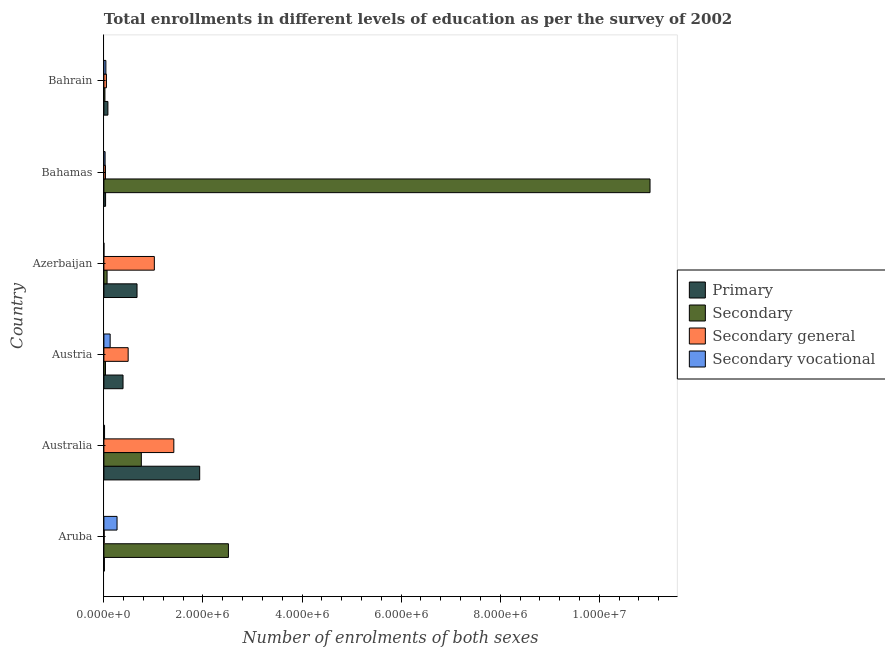How many groups of bars are there?
Offer a terse response. 6. Are the number of bars per tick equal to the number of legend labels?
Provide a short and direct response. Yes. Are the number of bars on each tick of the Y-axis equal?
Offer a terse response. Yes. How many bars are there on the 3rd tick from the top?
Provide a succinct answer. 4. How many bars are there on the 2nd tick from the bottom?
Your response must be concise. 4. What is the label of the 6th group of bars from the top?
Your answer should be very brief. Aruba. What is the number of enrolments in secondary general education in Bahamas?
Your answer should be very brief. 3.17e+04. Across all countries, what is the maximum number of enrolments in secondary education?
Your response must be concise. 1.10e+07. Across all countries, what is the minimum number of enrolments in primary education?
Keep it short and to the point. 9840. In which country was the number of enrolments in secondary general education maximum?
Provide a succinct answer. Australia. In which country was the number of enrolments in primary education minimum?
Offer a terse response. Aruba. What is the total number of enrolments in primary education in the graph?
Ensure brevity in your answer.  3.11e+06. What is the difference between the number of enrolments in primary education in Austria and that in Azerbaijan?
Provide a short and direct response. -2.82e+05. What is the difference between the number of enrolments in secondary vocational education in Azerbaijan and the number of enrolments in secondary general education in Aruba?
Provide a succinct answer. -5449. What is the average number of enrolments in primary education per country?
Keep it short and to the point. 5.19e+05. What is the difference between the number of enrolments in primary education and number of enrolments in secondary education in Bahrain?
Your answer should be very brief. 6.02e+04. What is the ratio of the number of enrolments in secondary general education in Azerbaijan to that in Bahamas?
Offer a very short reply. 32.12. What is the difference between the highest and the second highest number of enrolments in secondary vocational education?
Offer a terse response. 1.39e+05. What is the difference between the highest and the lowest number of enrolments in secondary vocational education?
Offer a terse response. 2.66e+05. In how many countries, is the number of enrolments in secondary vocational education greater than the average number of enrolments in secondary vocational education taken over all countries?
Your answer should be compact. 2. What does the 2nd bar from the top in Australia represents?
Offer a terse response. Secondary general. What does the 3rd bar from the bottom in Azerbaijan represents?
Provide a succinct answer. Secondary general. How many bars are there?
Offer a terse response. 24. How many countries are there in the graph?
Your answer should be very brief. 6. Are the values on the major ticks of X-axis written in scientific E-notation?
Offer a very short reply. Yes. Does the graph contain grids?
Your answer should be compact. No. Where does the legend appear in the graph?
Provide a succinct answer. Center right. How are the legend labels stacked?
Offer a very short reply. Vertical. What is the title of the graph?
Give a very brief answer. Total enrollments in different levels of education as per the survey of 2002. What is the label or title of the X-axis?
Ensure brevity in your answer.  Number of enrolments of both sexes. What is the label or title of the Y-axis?
Keep it short and to the point. Country. What is the Number of enrolments of both sexes in Primary in Aruba?
Your answer should be very brief. 9840. What is the Number of enrolments of both sexes of Secondary in Aruba?
Offer a terse response. 2.51e+06. What is the Number of enrolments of both sexes in Secondary general in Aruba?
Your response must be concise. 5559. What is the Number of enrolments of both sexes in Secondary vocational in Aruba?
Provide a short and direct response. 2.66e+05. What is the Number of enrolments of both sexes of Primary in Australia?
Your answer should be very brief. 1.93e+06. What is the Number of enrolments of both sexes of Secondary in Australia?
Ensure brevity in your answer.  7.56e+05. What is the Number of enrolments of both sexes of Secondary general in Australia?
Offer a very short reply. 1.41e+06. What is the Number of enrolments of both sexes in Secondary vocational in Australia?
Keep it short and to the point. 1.31e+04. What is the Number of enrolments of both sexes of Primary in Austria?
Make the answer very short. 3.86e+05. What is the Number of enrolments of both sexes in Secondary in Austria?
Ensure brevity in your answer.  3.17e+04. What is the Number of enrolments of both sexes in Secondary general in Austria?
Your answer should be very brief. 4.90e+05. What is the Number of enrolments of both sexes of Secondary vocational in Austria?
Give a very brief answer. 1.26e+05. What is the Number of enrolments of both sexes of Primary in Azerbaijan?
Provide a succinct answer. 6.69e+05. What is the Number of enrolments of both sexes in Secondary in Azerbaijan?
Your response must be concise. 6.44e+04. What is the Number of enrolments of both sexes in Secondary general in Azerbaijan?
Offer a very short reply. 1.02e+06. What is the Number of enrolments of both sexes in Secondary vocational in Azerbaijan?
Provide a succinct answer. 110. What is the Number of enrolments of both sexes of Primary in Bahamas?
Offer a terse response. 3.42e+04. What is the Number of enrolments of both sexes in Secondary in Bahamas?
Provide a short and direct response. 1.10e+07. What is the Number of enrolments of both sexes in Secondary general in Bahamas?
Your answer should be very brief. 3.17e+04. What is the Number of enrolments of both sexes of Secondary vocational in Bahamas?
Your answer should be very brief. 2.43e+04. What is the Number of enrolments of both sexes in Primary in Bahrain?
Provide a succinct answer. 8.11e+04. What is the Number of enrolments of both sexes of Secondary in Bahrain?
Keep it short and to the point. 2.09e+04. What is the Number of enrolments of both sexes in Secondary general in Bahrain?
Your answer should be compact. 5.13e+04. What is the Number of enrolments of both sexes in Secondary vocational in Bahrain?
Your response must be concise. 4.00e+04. Across all countries, what is the maximum Number of enrolments of both sexes in Primary?
Offer a terse response. 1.93e+06. Across all countries, what is the maximum Number of enrolments of both sexes in Secondary?
Provide a succinct answer. 1.10e+07. Across all countries, what is the maximum Number of enrolments of both sexes of Secondary general?
Provide a succinct answer. 1.41e+06. Across all countries, what is the maximum Number of enrolments of both sexes in Secondary vocational?
Ensure brevity in your answer.  2.66e+05. Across all countries, what is the minimum Number of enrolments of both sexes of Primary?
Offer a very short reply. 9840. Across all countries, what is the minimum Number of enrolments of both sexes in Secondary?
Your answer should be very brief. 2.09e+04. Across all countries, what is the minimum Number of enrolments of both sexes of Secondary general?
Provide a succinct answer. 5559. Across all countries, what is the minimum Number of enrolments of both sexes in Secondary vocational?
Make the answer very short. 110. What is the total Number of enrolments of both sexes of Primary in the graph?
Your answer should be very brief. 3.11e+06. What is the total Number of enrolments of both sexes of Secondary in the graph?
Give a very brief answer. 1.44e+07. What is the total Number of enrolments of both sexes in Secondary general in the graph?
Offer a terse response. 3.01e+06. What is the total Number of enrolments of both sexes of Secondary vocational in the graph?
Offer a very short reply. 4.70e+05. What is the difference between the Number of enrolments of both sexes of Primary in Aruba and that in Australia?
Your response must be concise. -1.92e+06. What is the difference between the Number of enrolments of both sexes in Secondary in Aruba and that in Australia?
Offer a terse response. 1.76e+06. What is the difference between the Number of enrolments of both sexes of Secondary general in Aruba and that in Australia?
Your answer should be compact. -1.41e+06. What is the difference between the Number of enrolments of both sexes of Secondary vocational in Aruba and that in Australia?
Provide a short and direct response. 2.53e+05. What is the difference between the Number of enrolments of both sexes of Primary in Aruba and that in Austria?
Offer a terse response. -3.77e+05. What is the difference between the Number of enrolments of both sexes of Secondary in Aruba and that in Austria?
Provide a short and direct response. 2.48e+06. What is the difference between the Number of enrolments of both sexes in Secondary general in Aruba and that in Austria?
Your answer should be very brief. -4.84e+05. What is the difference between the Number of enrolments of both sexes in Secondary vocational in Aruba and that in Austria?
Give a very brief answer. 1.39e+05. What is the difference between the Number of enrolments of both sexes of Primary in Aruba and that in Azerbaijan?
Provide a short and direct response. -6.59e+05. What is the difference between the Number of enrolments of both sexes of Secondary in Aruba and that in Azerbaijan?
Provide a short and direct response. 2.45e+06. What is the difference between the Number of enrolments of both sexes of Secondary general in Aruba and that in Azerbaijan?
Your response must be concise. -1.01e+06. What is the difference between the Number of enrolments of both sexes in Secondary vocational in Aruba and that in Azerbaijan?
Keep it short and to the point. 2.66e+05. What is the difference between the Number of enrolments of both sexes in Primary in Aruba and that in Bahamas?
Give a very brief answer. -2.43e+04. What is the difference between the Number of enrolments of both sexes in Secondary in Aruba and that in Bahamas?
Provide a short and direct response. -8.51e+06. What is the difference between the Number of enrolments of both sexes of Secondary general in Aruba and that in Bahamas?
Provide a short and direct response. -2.62e+04. What is the difference between the Number of enrolments of both sexes in Secondary vocational in Aruba and that in Bahamas?
Your response must be concise. 2.41e+05. What is the difference between the Number of enrolments of both sexes in Primary in Aruba and that in Bahrain?
Your answer should be very brief. -7.12e+04. What is the difference between the Number of enrolments of both sexes in Secondary in Aruba and that in Bahrain?
Your answer should be compact. 2.49e+06. What is the difference between the Number of enrolments of both sexes in Secondary general in Aruba and that in Bahrain?
Your answer should be very brief. -4.58e+04. What is the difference between the Number of enrolments of both sexes of Secondary vocational in Aruba and that in Bahrain?
Your answer should be very brief. 2.26e+05. What is the difference between the Number of enrolments of both sexes of Primary in Australia and that in Austria?
Your answer should be compact. 1.55e+06. What is the difference between the Number of enrolments of both sexes in Secondary in Australia and that in Austria?
Provide a short and direct response. 7.24e+05. What is the difference between the Number of enrolments of both sexes of Secondary general in Australia and that in Austria?
Offer a terse response. 9.22e+05. What is the difference between the Number of enrolments of both sexes of Secondary vocational in Australia and that in Austria?
Make the answer very short. -1.13e+05. What is the difference between the Number of enrolments of both sexes in Primary in Australia and that in Azerbaijan?
Provide a short and direct response. 1.26e+06. What is the difference between the Number of enrolments of both sexes of Secondary in Australia and that in Azerbaijan?
Make the answer very short. 6.91e+05. What is the difference between the Number of enrolments of both sexes in Secondary general in Australia and that in Azerbaijan?
Provide a short and direct response. 3.93e+05. What is the difference between the Number of enrolments of both sexes in Secondary vocational in Australia and that in Azerbaijan?
Give a very brief answer. 1.30e+04. What is the difference between the Number of enrolments of both sexes in Primary in Australia and that in Bahamas?
Your answer should be very brief. 1.90e+06. What is the difference between the Number of enrolments of both sexes in Secondary in Australia and that in Bahamas?
Give a very brief answer. -1.03e+07. What is the difference between the Number of enrolments of both sexes in Secondary general in Australia and that in Bahamas?
Offer a very short reply. 1.38e+06. What is the difference between the Number of enrolments of both sexes of Secondary vocational in Australia and that in Bahamas?
Ensure brevity in your answer.  -1.12e+04. What is the difference between the Number of enrolments of both sexes in Primary in Australia and that in Bahrain?
Provide a short and direct response. 1.85e+06. What is the difference between the Number of enrolments of both sexes in Secondary in Australia and that in Bahrain?
Your answer should be compact. 7.35e+05. What is the difference between the Number of enrolments of both sexes of Secondary general in Australia and that in Bahrain?
Your answer should be compact. 1.36e+06. What is the difference between the Number of enrolments of both sexes of Secondary vocational in Australia and that in Bahrain?
Give a very brief answer. -2.69e+04. What is the difference between the Number of enrolments of both sexes of Primary in Austria and that in Azerbaijan?
Offer a very short reply. -2.82e+05. What is the difference between the Number of enrolments of both sexes of Secondary in Austria and that in Azerbaijan?
Ensure brevity in your answer.  -3.27e+04. What is the difference between the Number of enrolments of both sexes in Secondary general in Austria and that in Azerbaijan?
Offer a very short reply. -5.29e+05. What is the difference between the Number of enrolments of both sexes in Secondary vocational in Austria and that in Azerbaijan?
Provide a short and direct response. 1.26e+05. What is the difference between the Number of enrolments of both sexes in Primary in Austria and that in Bahamas?
Your response must be concise. 3.52e+05. What is the difference between the Number of enrolments of both sexes of Secondary in Austria and that in Bahamas?
Make the answer very short. -1.10e+07. What is the difference between the Number of enrolments of both sexes of Secondary general in Austria and that in Bahamas?
Give a very brief answer. 4.58e+05. What is the difference between the Number of enrolments of both sexes of Secondary vocational in Austria and that in Bahamas?
Offer a terse response. 1.02e+05. What is the difference between the Number of enrolments of both sexes of Primary in Austria and that in Bahrain?
Ensure brevity in your answer.  3.05e+05. What is the difference between the Number of enrolments of both sexes in Secondary in Austria and that in Bahrain?
Keep it short and to the point. 1.08e+04. What is the difference between the Number of enrolments of both sexes in Secondary general in Austria and that in Bahrain?
Keep it short and to the point. 4.39e+05. What is the difference between the Number of enrolments of both sexes in Secondary vocational in Austria and that in Bahrain?
Make the answer very short. 8.63e+04. What is the difference between the Number of enrolments of both sexes in Primary in Azerbaijan and that in Bahamas?
Your answer should be compact. 6.35e+05. What is the difference between the Number of enrolments of both sexes in Secondary in Azerbaijan and that in Bahamas?
Your response must be concise. -1.10e+07. What is the difference between the Number of enrolments of both sexes in Secondary general in Azerbaijan and that in Bahamas?
Give a very brief answer. 9.87e+05. What is the difference between the Number of enrolments of both sexes of Secondary vocational in Azerbaijan and that in Bahamas?
Offer a terse response. -2.42e+04. What is the difference between the Number of enrolments of both sexes of Primary in Azerbaijan and that in Bahrain?
Your answer should be very brief. 5.88e+05. What is the difference between the Number of enrolments of both sexes in Secondary in Azerbaijan and that in Bahrain?
Provide a succinct answer. 4.36e+04. What is the difference between the Number of enrolments of both sexes of Secondary general in Azerbaijan and that in Bahrain?
Provide a short and direct response. 9.67e+05. What is the difference between the Number of enrolments of both sexes in Secondary vocational in Azerbaijan and that in Bahrain?
Provide a short and direct response. -3.99e+04. What is the difference between the Number of enrolments of both sexes of Primary in Bahamas and that in Bahrain?
Provide a short and direct response. -4.69e+04. What is the difference between the Number of enrolments of both sexes in Secondary in Bahamas and that in Bahrain?
Ensure brevity in your answer.  1.10e+07. What is the difference between the Number of enrolments of both sexes in Secondary general in Bahamas and that in Bahrain?
Your response must be concise. -1.96e+04. What is the difference between the Number of enrolments of both sexes in Secondary vocational in Bahamas and that in Bahrain?
Provide a succinct answer. -1.57e+04. What is the difference between the Number of enrolments of both sexes of Primary in Aruba and the Number of enrolments of both sexes of Secondary in Australia?
Your response must be concise. -7.46e+05. What is the difference between the Number of enrolments of both sexes in Primary in Aruba and the Number of enrolments of both sexes in Secondary general in Australia?
Provide a short and direct response. -1.40e+06. What is the difference between the Number of enrolments of both sexes of Primary in Aruba and the Number of enrolments of both sexes of Secondary vocational in Australia?
Keep it short and to the point. -3275. What is the difference between the Number of enrolments of both sexes in Secondary in Aruba and the Number of enrolments of both sexes in Secondary general in Australia?
Your answer should be compact. 1.10e+06. What is the difference between the Number of enrolments of both sexes of Secondary in Aruba and the Number of enrolments of both sexes of Secondary vocational in Australia?
Your answer should be very brief. 2.50e+06. What is the difference between the Number of enrolments of both sexes of Secondary general in Aruba and the Number of enrolments of both sexes of Secondary vocational in Australia?
Your response must be concise. -7556. What is the difference between the Number of enrolments of both sexes in Primary in Aruba and the Number of enrolments of both sexes in Secondary in Austria?
Give a very brief answer. -2.19e+04. What is the difference between the Number of enrolments of both sexes in Primary in Aruba and the Number of enrolments of both sexes in Secondary general in Austria?
Offer a terse response. -4.80e+05. What is the difference between the Number of enrolments of both sexes in Primary in Aruba and the Number of enrolments of both sexes in Secondary vocational in Austria?
Your answer should be very brief. -1.17e+05. What is the difference between the Number of enrolments of both sexes of Secondary in Aruba and the Number of enrolments of both sexes of Secondary general in Austria?
Offer a terse response. 2.02e+06. What is the difference between the Number of enrolments of both sexes in Secondary in Aruba and the Number of enrolments of both sexes in Secondary vocational in Austria?
Your answer should be very brief. 2.39e+06. What is the difference between the Number of enrolments of both sexes in Secondary general in Aruba and the Number of enrolments of both sexes in Secondary vocational in Austria?
Offer a terse response. -1.21e+05. What is the difference between the Number of enrolments of both sexes of Primary in Aruba and the Number of enrolments of both sexes of Secondary in Azerbaijan?
Make the answer very short. -5.46e+04. What is the difference between the Number of enrolments of both sexes in Primary in Aruba and the Number of enrolments of both sexes in Secondary general in Azerbaijan?
Offer a terse response. -1.01e+06. What is the difference between the Number of enrolments of both sexes of Primary in Aruba and the Number of enrolments of both sexes of Secondary vocational in Azerbaijan?
Your answer should be very brief. 9730. What is the difference between the Number of enrolments of both sexes in Secondary in Aruba and the Number of enrolments of both sexes in Secondary general in Azerbaijan?
Provide a succinct answer. 1.50e+06. What is the difference between the Number of enrolments of both sexes of Secondary in Aruba and the Number of enrolments of both sexes of Secondary vocational in Azerbaijan?
Your response must be concise. 2.51e+06. What is the difference between the Number of enrolments of both sexes of Secondary general in Aruba and the Number of enrolments of both sexes of Secondary vocational in Azerbaijan?
Ensure brevity in your answer.  5449. What is the difference between the Number of enrolments of both sexes of Primary in Aruba and the Number of enrolments of both sexes of Secondary in Bahamas?
Your answer should be very brief. -1.10e+07. What is the difference between the Number of enrolments of both sexes in Primary in Aruba and the Number of enrolments of both sexes in Secondary general in Bahamas?
Ensure brevity in your answer.  -2.19e+04. What is the difference between the Number of enrolments of both sexes of Primary in Aruba and the Number of enrolments of both sexes of Secondary vocational in Bahamas?
Your answer should be compact. -1.45e+04. What is the difference between the Number of enrolments of both sexes in Secondary in Aruba and the Number of enrolments of both sexes in Secondary general in Bahamas?
Offer a very short reply. 2.48e+06. What is the difference between the Number of enrolments of both sexes in Secondary in Aruba and the Number of enrolments of both sexes in Secondary vocational in Bahamas?
Make the answer very short. 2.49e+06. What is the difference between the Number of enrolments of both sexes in Secondary general in Aruba and the Number of enrolments of both sexes in Secondary vocational in Bahamas?
Provide a succinct answer. -1.88e+04. What is the difference between the Number of enrolments of both sexes in Primary in Aruba and the Number of enrolments of both sexes in Secondary in Bahrain?
Keep it short and to the point. -1.10e+04. What is the difference between the Number of enrolments of both sexes in Primary in Aruba and the Number of enrolments of both sexes in Secondary general in Bahrain?
Make the answer very short. -4.15e+04. What is the difference between the Number of enrolments of both sexes in Primary in Aruba and the Number of enrolments of both sexes in Secondary vocational in Bahrain?
Offer a terse response. -3.02e+04. What is the difference between the Number of enrolments of both sexes of Secondary in Aruba and the Number of enrolments of both sexes of Secondary general in Bahrain?
Make the answer very short. 2.46e+06. What is the difference between the Number of enrolments of both sexes of Secondary in Aruba and the Number of enrolments of both sexes of Secondary vocational in Bahrain?
Keep it short and to the point. 2.47e+06. What is the difference between the Number of enrolments of both sexes in Secondary general in Aruba and the Number of enrolments of both sexes in Secondary vocational in Bahrain?
Offer a very short reply. -3.45e+04. What is the difference between the Number of enrolments of both sexes of Primary in Australia and the Number of enrolments of both sexes of Secondary in Austria?
Keep it short and to the point. 1.90e+06. What is the difference between the Number of enrolments of both sexes of Primary in Australia and the Number of enrolments of both sexes of Secondary general in Austria?
Your answer should be compact. 1.44e+06. What is the difference between the Number of enrolments of both sexes of Primary in Australia and the Number of enrolments of both sexes of Secondary vocational in Austria?
Offer a terse response. 1.81e+06. What is the difference between the Number of enrolments of both sexes of Secondary in Australia and the Number of enrolments of both sexes of Secondary general in Austria?
Offer a very short reply. 2.66e+05. What is the difference between the Number of enrolments of both sexes in Secondary in Australia and the Number of enrolments of both sexes in Secondary vocational in Austria?
Give a very brief answer. 6.29e+05. What is the difference between the Number of enrolments of both sexes in Secondary general in Australia and the Number of enrolments of both sexes in Secondary vocational in Austria?
Provide a short and direct response. 1.29e+06. What is the difference between the Number of enrolments of both sexes of Primary in Australia and the Number of enrolments of both sexes of Secondary in Azerbaijan?
Provide a short and direct response. 1.87e+06. What is the difference between the Number of enrolments of both sexes of Primary in Australia and the Number of enrolments of both sexes of Secondary general in Azerbaijan?
Offer a terse response. 9.15e+05. What is the difference between the Number of enrolments of both sexes of Primary in Australia and the Number of enrolments of both sexes of Secondary vocational in Azerbaijan?
Give a very brief answer. 1.93e+06. What is the difference between the Number of enrolments of both sexes in Secondary in Australia and the Number of enrolments of both sexes in Secondary general in Azerbaijan?
Your response must be concise. -2.63e+05. What is the difference between the Number of enrolments of both sexes in Secondary in Australia and the Number of enrolments of both sexes in Secondary vocational in Azerbaijan?
Keep it short and to the point. 7.55e+05. What is the difference between the Number of enrolments of both sexes of Secondary general in Australia and the Number of enrolments of both sexes of Secondary vocational in Azerbaijan?
Your response must be concise. 1.41e+06. What is the difference between the Number of enrolments of both sexes in Primary in Australia and the Number of enrolments of both sexes in Secondary in Bahamas?
Offer a very short reply. -9.09e+06. What is the difference between the Number of enrolments of both sexes of Primary in Australia and the Number of enrolments of both sexes of Secondary general in Bahamas?
Your answer should be compact. 1.90e+06. What is the difference between the Number of enrolments of both sexes in Primary in Australia and the Number of enrolments of both sexes in Secondary vocational in Bahamas?
Give a very brief answer. 1.91e+06. What is the difference between the Number of enrolments of both sexes of Secondary in Australia and the Number of enrolments of both sexes of Secondary general in Bahamas?
Ensure brevity in your answer.  7.24e+05. What is the difference between the Number of enrolments of both sexes in Secondary in Australia and the Number of enrolments of both sexes in Secondary vocational in Bahamas?
Provide a short and direct response. 7.31e+05. What is the difference between the Number of enrolments of both sexes in Secondary general in Australia and the Number of enrolments of both sexes in Secondary vocational in Bahamas?
Your answer should be very brief. 1.39e+06. What is the difference between the Number of enrolments of both sexes of Primary in Australia and the Number of enrolments of both sexes of Secondary in Bahrain?
Provide a succinct answer. 1.91e+06. What is the difference between the Number of enrolments of both sexes in Primary in Australia and the Number of enrolments of both sexes in Secondary general in Bahrain?
Your answer should be very brief. 1.88e+06. What is the difference between the Number of enrolments of both sexes of Primary in Australia and the Number of enrolments of both sexes of Secondary vocational in Bahrain?
Your answer should be compact. 1.89e+06. What is the difference between the Number of enrolments of both sexes of Secondary in Australia and the Number of enrolments of both sexes of Secondary general in Bahrain?
Your response must be concise. 7.04e+05. What is the difference between the Number of enrolments of both sexes in Secondary in Australia and the Number of enrolments of both sexes in Secondary vocational in Bahrain?
Give a very brief answer. 7.16e+05. What is the difference between the Number of enrolments of both sexes in Secondary general in Australia and the Number of enrolments of both sexes in Secondary vocational in Bahrain?
Your answer should be compact. 1.37e+06. What is the difference between the Number of enrolments of both sexes of Primary in Austria and the Number of enrolments of both sexes of Secondary in Azerbaijan?
Your answer should be compact. 3.22e+05. What is the difference between the Number of enrolments of both sexes in Primary in Austria and the Number of enrolments of both sexes in Secondary general in Azerbaijan?
Your answer should be compact. -6.32e+05. What is the difference between the Number of enrolments of both sexes of Primary in Austria and the Number of enrolments of both sexes of Secondary vocational in Azerbaijan?
Offer a very short reply. 3.86e+05. What is the difference between the Number of enrolments of both sexes of Secondary in Austria and the Number of enrolments of both sexes of Secondary general in Azerbaijan?
Keep it short and to the point. -9.87e+05. What is the difference between the Number of enrolments of both sexes of Secondary in Austria and the Number of enrolments of both sexes of Secondary vocational in Azerbaijan?
Provide a short and direct response. 3.16e+04. What is the difference between the Number of enrolments of both sexes of Secondary general in Austria and the Number of enrolments of both sexes of Secondary vocational in Azerbaijan?
Provide a succinct answer. 4.90e+05. What is the difference between the Number of enrolments of both sexes in Primary in Austria and the Number of enrolments of both sexes in Secondary in Bahamas?
Your answer should be compact. -1.06e+07. What is the difference between the Number of enrolments of both sexes in Primary in Austria and the Number of enrolments of both sexes in Secondary general in Bahamas?
Your answer should be very brief. 3.55e+05. What is the difference between the Number of enrolments of both sexes of Primary in Austria and the Number of enrolments of both sexes of Secondary vocational in Bahamas?
Keep it short and to the point. 3.62e+05. What is the difference between the Number of enrolments of both sexes in Secondary in Austria and the Number of enrolments of both sexes in Secondary general in Bahamas?
Make the answer very short. 0. What is the difference between the Number of enrolments of both sexes in Secondary in Austria and the Number of enrolments of both sexes in Secondary vocational in Bahamas?
Offer a terse response. 7371. What is the difference between the Number of enrolments of both sexes of Secondary general in Austria and the Number of enrolments of both sexes of Secondary vocational in Bahamas?
Offer a terse response. 4.66e+05. What is the difference between the Number of enrolments of both sexes in Primary in Austria and the Number of enrolments of both sexes in Secondary in Bahrain?
Offer a very short reply. 3.66e+05. What is the difference between the Number of enrolments of both sexes of Primary in Austria and the Number of enrolments of both sexes of Secondary general in Bahrain?
Your answer should be compact. 3.35e+05. What is the difference between the Number of enrolments of both sexes in Primary in Austria and the Number of enrolments of both sexes in Secondary vocational in Bahrain?
Ensure brevity in your answer.  3.46e+05. What is the difference between the Number of enrolments of both sexes of Secondary in Austria and the Number of enrolments of both sexes of Secondary general in Bahrain?
Provide a short and direct response. -1.96e+04. What is the difference between the Number of enrolments of both sexes in Secondary in Austria and the Number of enrolments of both sexes in Secondary vocational in Bahrain?
Provide a short and direct response. -8317. What is the difference between the Number of enrolments of both sexes in Secondary general in Austria and the Number of enrolments of both sexes in Secondary vocational in Bahrain?
Offer a terse response. 4.50e+05. What is the difference between the Number of enrolments of both sexes in Primary in Azerbaijan and the Number of enrolments of both sexes in Secondary in Bahamas?
Your answer should be compact. -1.04e+07. What is the difference between the Number of enrolments of both sexes of Primary in Azerbaijan and the Number of enrolments of both sexes of Secondary general in Bahamas?
Offer a very short reply. 6.37e+05. What is the difference between the Number of enrolments of both sexes of Primary in Azerbaijan and the Number of enrolments of both sexes of Secondary vocational in Bahamas?
Your answer should be compact. 6.45e+05. What is the difference between the Number of enrolments of both sexes in Secondary in Azerbaijan and the Number of enrolments of both sexes in Secondary general in Bahamas?
Keep it short and to the point. 3.27e+04. What is the difference between the Number of enrolments of both sexes in Secondary in Azerbaijan and the Number of enrolments of both sexes in Secondary vocational in Bahamas?
Offer a terse response. 4.01e+04. What is the difference between the Number of enrolments of both sexes in Secondary general in Azerbaijan and the Number of enrolments of both sexes in Secondary vocational in Bahamas?
Provide a short and direct response. 9.94e+05. What is the difference between the Number of enrolments of both sexes in Primary in Azerbaijan and the Number of enrolments of both sexes in Secondary in Bahrain?
Give a very brief answer. 6.48e+05. What is the difference between the Number of enrolments of both sexes in Primary in Azerbaijan and the Number of enrolments of both sexes in Secondary general in Bahrain?
Your answer should be very brief. 6.18e+05. What is the difference between the Number of enrolments of both sexes of Primary in Azerbaijan and the Number of enrolments of both sexes of Secondary vocational in Bahrain?
Provide a succinct answer. 6.29e+05. What is the difference between the Number of enrolments of both sexes of Secondary in Azerbaijan and the Number of enrolments of both sexes of Secondary general in Bahrain?
Your answer should be very brief. 1.31e+04. What is the difference between the Number of enrolments of both sexes of Secondary in Azerbaijan and the Number of enrolments of both sexes of Secondary vocational in Bahrain?
Your answer should be very brief. 2.44e+04. What is the difference between the Number of enrolments of both sexes of Secondary general in Azerbaijan and the Number of enrolments of both sexes of Secondary vocational in Bahrain?
Offer a very short reply. 9.79e+05. What is the difference between the Number of enrolments of both sexes in Primary in Bahamas and the Number of enrolments of both sexes in Secondary in Bahrain?
Make the answer very short. 1.33e+04. What is the difference between the Number of enrolments of both sexes in Primary in Bahamas and the Number of enrolments of both sexes in Secondary general in Bahrain?
Your answer should be compact. -1.72e+04. What is the difference between the Number of enrolments of both sexes of Primary in Bahamas and the Number of enrolments of both sexes of Secondary vocational in Bahrain?
Offer a terse response. -5877. What is the difference between the Number of enrolments of both sexes of Secondary in Bahamas and the Number of enrolments of both sexes of Secondary general in Bahrain?
Your response must be concise. 1.10e+07. What is the difference between the Number of enrolments of both sexes of Secondary in Bahamas and the Number of enrolments of both sexes of Secondary vocational in Bahrain?
Keep it short and to the point. 1.10e+07. What is the difference between the Number of enrolments of both sexes of Secondary general in Bahamas and the Number of enrolments of both sexes of Secondary vocational in Bahrain?
Ensure brevity in your answer.  -8317. What is the average Number of enrolments of both sexes in Primary per country?
Your answer should be very brief. 5.19e+05. What is the average Number of enrolments of both sexes in Secondary per country?
Offer a very short reply. 2.40e+06. What is the average Number of enrolments of both sexes in Secondary general per country?
Offer a very short reply. 5.01e+05. What is the average Number of enrolments of both sexes of Secondary vocational per country?
Offer a very short reply. 7.83e+04. What is the difference between the Number of enrolments of both sexes of Primary and Number of enrolments of both sexes of Secondary in Aruba?
Keep it short and to the point. -2.50e+06. What is the difference between the Number of enrolments of both sexes of Primary and Number of enrolments of both sexes of Secondary general in Aruba?
Your answer should be very brief. 4281. What is the difference between the Number of enrolments of both sexes of Primary and Number of enrolments of both sexes of Secondary vocational in Aruba?
Keep it short and to the point. -2.56e+05. What is the difference between the Number of enrolments of both sexes in Secondary and Number of enrolments of both sexes in Secondary general in Aruba?
Your answer should be compact. 2.51e+06. What is the difference between the Number of enrolments of both sexes in Secondary and Number of enrolments of both sexes in Secondary vocational in Aruba?
Keep it short and to the point. 2.25e+06. What is the difference between the Number of enrolments of both sexes of Secondary general and Number of enrolments of both sexes of Secondary vocational in Aruba?
Offer a very short reply. -2.60e+05. What is the difference between the Number of enrolments of both sexes of Primary and Number of enrolments of both sexes of Secondary in Australia?
Provide a succinct answer. 1.18e+06. What is the difference between the Number of enrolments of both sexes of Primary and Number of enrolments of both sexes of Secondary general in Australia?
Keep it short and to the point. 5.22e+05. What is the difference between the Number of enrolments of both sexes in Primary and Number of enrolments of both sexes in Secondary vocational in Australia?
Give a very brief answer. 1.92e+06. What is the difference between the Number of enrolments of both sexes in Secondary and Number of enrolments of both sexes in Secondary general in Australia?
Offer a terse response. -6.56e+05. What is the difference between the Number of enrolments of both sexes in Secondary and Number of enrolments of both sexes in Secondary vocational in Australia?
Provide a succinct answer. 7.42e+05. What is the difference between the Number of enrolments of both sexes in Secondary general and Number of enrolments of both sexes in Secondary vocational in Australia?
Give a very brief answer. 1.40e+06. What is the difference between the Number of enrolments of both sexes in Primary and Number of enrolments of both sexes in Secondary in Austria?
Keep it short and to the point. 3.55e+05. What is the difference between the Number of enrolments of both sexes in Primary and Number of enrolments of both sexes in Secondary general in Austria?
Offer a terse response. -1.03e+05. What is the difference between the Number of enrolments of both sexes of Primary and Number of enrolments of both sexes of Secondary vocational in Austria?
Provide a short and direct response. 2.60e+05. What is the difference between the Number of enrolments of both sexes of Secondary and Number of enrolments of both sexes of Secondary general in Austria?
Give a very brief answer. -4.58e+05. What is the difference between the Number of enrolments of both sexes in Secondary and Number of enrolments of both sexes in Secondary vocational in Austria?
Make the answer very short. -9.46e+04. What is the difference between the Number of enrolments of both sexes of Secondary general and Number of enrolments of both sexes of Secondary vocational in Austria?
Offer a terse response. 3.64e+05. What is the difference between the Number of enrolments of both sexes in Primary and Number of enrolments of both sexes in Secondary in Azerbaijan?
Ensure brevity in your answer.  6.04e+05. What is the difference between the Number of enrolments of both sexes of Primary and Number of enrolments of both sexes of Secondary general in Azerbaijan?
Ensure brevity in your answer.  -3.50e+05. What is the difference between the Number of enrolments of both sexes in Primary and Number of enrolments of both sexes in Secondary vocational in Azerbaijan?
Ensure brevity in your answer.  6.69e+05. What is the difference between the Number of enrolments of both sexes in Secondary and Number of enrolments of both sexes in Secondary general in Azerbaijan?
Provide a short and direct response. -9.54e+05. What is the difference between the Number of enrolments of both sexes in Secondary and Number of enrolments of both sexes in Secondary vocational in Azerbaijan?
Your response must be concise. 6.43e+04. What is the difference between the Number of enrolments of both sexes in Secondary general and Number of enrolments of both sexes in Secondary vocational in Azerbaijan?
Offer a terse response. 1.02e+06. What is the difference between the Number of enrolments of both sexes in Primary and Number of enrolments of both sexes in Secondary in Bahamas?
Provide a succinct answer. -1.10e+07. What is the difference between the Number of enrolments of both sexes in Primary and Number of enrolments of both sexes in Secondary general in Bahamas?
Provide a succinct answer. 2440. What is the difference between the Number of enrolments of both sexes in Primary and Number of enrolments of both sexes in Secondary vocational in Bahamas?
Keep it short and to the point. 9811. What is the difference between the Number of enrolments of both sexes of Secondary and Number of enrolments of both sexes of Secondary general in Bahamas?
Give a very brief answer. 1.10e+07. What is the difference between the Number of enrolments of both sexes in Secondary and Number of enrolments of both sexes in Secondary vocational in Bahamas?
Offer a terse response. 1.10e+07. What is the difference between the Number of enrolments of both sexes of Secondary general and Number of enrolments of both sexes of Secondary vocational in Bahamas?
Provide a short and direct response. 7371. What is the difference between the Number of enrolments of both sexes of Primary and Number of enrolments of both sexes of Secondary in Bahrain?
Your response must be concise. 6.02e+04. What is the difference between the Number of enrolments of both sexes in Primary and Number of enrolments of both sexes in Secondary general in Bahrain?
Make the answer very short. 2.97e+04. What is the difference between the Number of enrolments of both sexes of Primary and Number of enrolments of both sexes of Secondary vocational in Bahrain?
Give a very brief answer. 4.10e+04. What is the difference between the Number of enrolments of both sexes of Secondary and Number of enrolments of both sexes of Secondary general in Bahrain?
Provide a succinct answer. -3.05e+04. What is the difference between the Number of enrolments of both sexes in Secondary and Number of enrolments of both sexes in Secondary vocational in Bahrain?
Your answer should be compact. -1.92e+04. What is the difference between the Number of enrolments of both sexes of Secondary general and Number of enrolments of both sexes of Secondary vocational in Bahrain?
Your response must be concise. 1.13e+04. What is the ratio of the Number of enrolments of both sexes of Primary in Aruba to that in Australia?
Offer a terse response. 0.01. What is the ratio of the Number of enrolments of both sexes of Secondary in Aruba to that in Australia?
Keep it short and to the point. 3.33. What is the ratio of the Number of enrolments of both sexes of Secondary general in Aruba to that in Australia?
Your answer should be very brief. 0. What is the ratio of the Number of enrolments of both sexes of Secondary vocational in Aruba to that in Australia?
Your answer should be compact. 20.26. What is the ratio of the Number of enrolments of both sexes in Primary in Aruba to that in Austria?
Give a very brief answer. 0.03. What is the ratio of the Number of enrolments of both sexes in Secondary in Aruba to that in Austria?
Make the answer very short. 79.26. What is the ratio of the Number of enrolments of both sexes of Secondary general in Aruba to that in Austria?
Offer a very short reply. 0.01. What is the ratio of the Number of enrolments of both sexes in Secondary vocational in Aruba to that in Austria?
Ensure brevity in your answer.  2.1. What is the ratio of the Number of enrolments of both sexes of Primary in Aruba to that in Azerbaijan?
Offer a very short reply. 0.01. What is the ratio of the Number of enrolments of both sexes of Secondary in Aruba to that in Azerbaijan?
Ensure brevity in your answer.  39.01. What is the ratio of the Number of enrolments of both sexes of Secondary general in Aruba to that in Azerbaijan?
Offer a very short reply. 0.01. What is the ratio of the Number of enrolments of both sexes of Secondary vocational in Aruba to that in Azerbaijan?
Give a very brief answer. 2414.95. What is the ratio of the Number of enrolments of both sexes in Primary in Aruba to that in Bahamas?
Offer a terse response. 0.29. What is the ratio of the Number of enrolments of both sexes in Secondary in Aruba to that in Bahamas?
Give a very brief answer. 0.23. What is the ratio of the Number of enrolments of both sexes of Secondary general in Aruba to that in Bahamas?
Give a very brief answer. 0.18. What is the ratio of the Number of enrolments of both sexes in Secondary vocational in Aruba to that in Bahamas?
Offer a very short reply. 10.91. What is the ratio of the Number of enrolments of both sexes of Primary in Aruba to that in Bahrain?
Make the answer very short. 0.12. What is the ratio of the Number of enrolments of both sexes in Secondary in Aruba to that in Bahrain?
Your answer should be very brief. 120.43. What is the ratio of the Number of enrolments of both sexes in Secondary general in Aruba to that in Bahrain?
Offer a very short reply. 0.11. What is the ratio of the Number of enrolments of both sexes of Secondary vocational in Aruba to that in Bahrain?
Make the answer very short. 6.64. What is the ratio of the Number of enrolments of both sexes in Primary in Australia to that in Austria?
Ensure brevity in your answer.  5. What is the ratio of the Number of enrolments of both sexes of Secondary in Australia to that in Austria?
Ensure brevity in your answer.  23.83. What is the ratio of the Number of enrolments of both sexes of Secondary general in Australia to that in Austria?
Make the answer very short. 2.88. What is the ratio of the Number of enrolments of both sexes in Secondary vocational in Australia to that in Austria?
Make the answer very short. 0.1. What is the ratio of the Number of enrolments of both sexes in Primary in Australia to that in Azerbaijan?
Make the answer very short. 2.89. What is the ratio of the Number of enrolments of both sexes in Secondary in Australia to that in Azerbaijan?
Your response must be concise. 11.73. What is the ratio of the Number of enrolments of both sexes of Secondary general in Australia to that in Azerbaijan?
Offer a very short reply. 1.39. What is the ratio of the Number of enrolments of both sexes in Secondary vocational in Australia to that in Azerbaijan?
Keep it short and to the point. 119.23. What is the ratio of the Number of enrolments of both sexes in Primary in Australia to that in Bahamas?
Ensure brevity in your answer.  56.62. What is the ratio of the Number of enrolments of both sexes in Secondary in Australia to that in Bahamas?
Offer a terse response. 0.07. What is the ratio of the Number of enrolments of both sexes of Secondary general in Australia to that in Bahamas?
Provide a short and direct response. 44.51. What is the ratio of the Number of enrolments of both sexes of Secondary vocational in Australia to that in Bahamas?
Make the answer very short. 0.54. What is the ratio of the Number of enrolments of both sexes of Primary in Australia to that in Bahrain?
Provide a short and direct response. 23.86. What is the ratio of the Number of enrolments of both sexes in Secondary in Australia to that in Bahrain?
Offer a very short reply. 36.2. What is the ratio of the Number of enrolments of both sexes of Secondary general in Australia to that in Bahrain?
Your answer should be very brief. 27.5. What is the ratio of the Number of enrolments of both sexes of Secondary vocational in Australia to that in Bahrain?
Provide a succinct answer. 0.33. What is the ratio of the Number of enrolments of both sexes of Primary in Austria to that in Azerbaijan?
Provide a succinct answer. 0.58. What is the ratio of the Number of enrolments of both sexes of Secondary in Austria to that in Azerbaijan?
Provide a succinct answer. 0.49. What is the ratio of the Number of enrolments of both sexes of Secondary general in Austria to that in Azerbaijan?
Your response must be concise. 0.48. What is the ratio of the Number of enrolments of both sexes in Secondary vocational in Austria to that in Azerbaijan?
Your answer should be compact. 1148.68. What is the ratio of the Number of enrolments of both sexes of Primary in Austria to that in Bahamas?
Make the answer very short. 11.32. What is the ratio of the Number of enrolments of both sexes of Secondary in Austria to that in Bahamas?
Make the answer very short. 0. What is the ratio of the Number of enrolments of both sexes in Secondary general in Austria to that in Bahamas?
Offer a very short reply. 15.45. What is the ratio of the Number of enrolments of both sexes in Secondary vocational in Austria to that in Bahamas?
Give a very brief answer. 5.19. What is the ratio of the Number of enrolments of both sexes in Primary in Austria to that in Bahrain?
Your answer should be compact. 4.77. What is the ratio of the Number of enrolments of both sexes of Secondary in Austria to that in Bahrain?
Ensure brevity in your answer.  1.52. What is the ratio of the Number of enrolments of both sexes in Secondary general in Austria to that in Bahrain?
Your answer should be very brief. 9.55. What is the ratio of the Number of enrolments of both sexes of Secondary vocational in Austria to that in Bahrain?
Keep it short and to the point. 3.16. What is the ratio of the Number of enrolments of both sexes of Primary in Azerbaijan to that in Bahamas?
Your response must be concise. 19.59. What is the ratio of the Number of enrolments of both sexes of Secondary in Azerbaijan to that in Bahamas?
Your answer should be compact. 0.01. What is the ratio of the Number of enrolments of both sexes in Secondary general in Azerbaijan to that in Bahamas?
Your answer should be very brief. 32.12. What is the ratio of the Number of enrolments of both sexes in Secondary vocational in Azerbaijan to that in Bahamas?
Offer a very short reply. 0. What is the ratio of the Number of enrolments of both sexes of Primary in Azerbaijan to that in Bahrain?
Provide a succinct answer. 8.25. What is the ratio of the Number of enrolments of both sexes in Secondary in Azerbaijan to that in Bahrain?
Your answer should be very brief. 3.09. What is the ratio of the Number of enrolments of both sexes of Secondary general in Azerbaijan to that in Bahrain?
Make the answer very short. 19.85. What is the ratio of the Number of enrolments of both sexes of Secondary vocational in Azerbaijan to that in Bahrain?
Your response must be concise. 0. What is the ratio of the Number of enrolments of both sexes in Primary in Bahamas to that in Bahrain?
Give a very brief answer. 0.42. What is the ratio of the Number of enrolments of both sexes in Secondary in Bahamas to that in Bahrain?
Ensure brevity in your answer.  528.19. What is the ratio of the Number of enrolments of both sexes of Secondary general in Bahamas to that in Bahrain?
Your answer should be compact. 0.62. What is the ratio of the Number of enrolments of both sexes of Secondary vocational in Bahamas to that in Bahrain?
Provide a succinct answer. 0.61. What is the difference between the highest and the second highest Number of enrolments of both sexes in Primary?
Give a very brief answer. 1.26e+06. What is the difference between the highest and the second highest Number of enrolments of both sexes in Secondary?
Provide a succinct answer. 8.51e+06. What is the difference between the highest and the second highest Number of enrolments of both sexes in Secondary general?
Your answer should be compact. 3.93e+05. What is the difference between the highest and the second highest Number of enrolments of both sexes of Secondary vocational?
Your answer should be compact. 1.39e+05. What is the difference between the highest and the lowest Number of enrolments of both sexes in Primary?
Offer a terse response. 1.92e+06. What is the difference between the highest and the lowest Number of enrolments of both sexes in Secondary?
Provide a succinct answer. 1.10e+07. What is the difference between the highest and the lowest Number of enrolments of both sexes of Secondary general?
Give a very brief answer. 1.41e+06. What is the difference between the highest and the lowest Number of enrolments of both sexes in Secondary vocational?
Make the answer very short. 2.66e+05. 